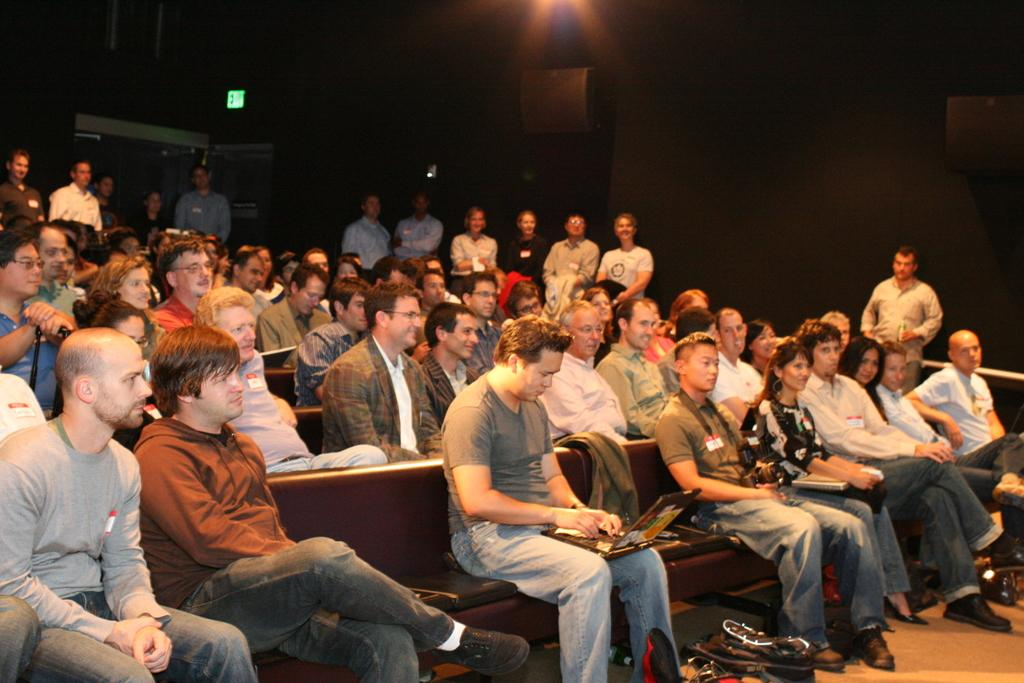How many people are in the image? There is a group of people in the image, but the exact number is not specified. What are the people in the image doing? Some people are seated, and some people are standing. Are there any objects being held by the people in the image? Yes, there are people holding laptops in the image. What type of skin is visible on the people holding laptops in the image? There is no information about the skin of the people holding laptops in the image, and therefore it cannot be determined. 